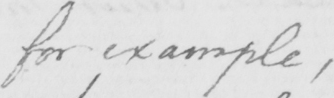Transcribe the text shown in this historical manuscript line. for example  , 